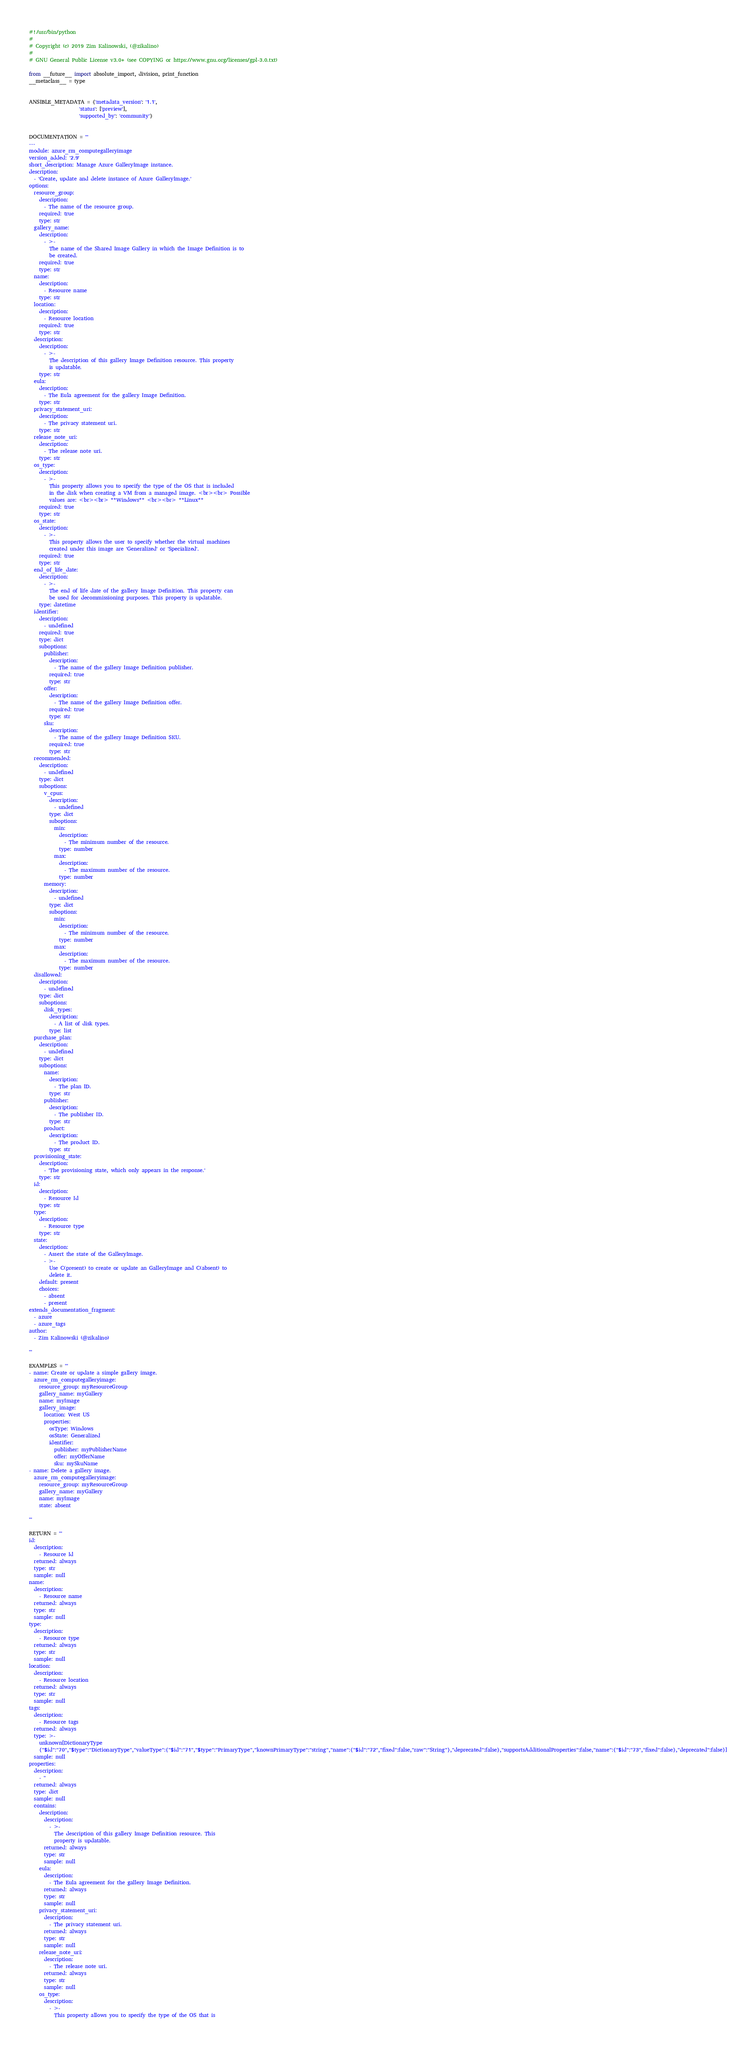Convert code to text. <code><loc_0><loc_0><loc_500><loc_500><_Python_>#!/usr/bin/python
#
# Copyright (c) 2019 Zim Kalinowski, (@zikalino)
#
# GNU General Public License v3.0+ (see COPYING or https://www.gnu.org/licenses/gpl-3.0.txt)

from __future__ import absolute_import, division, print_function
__metaclass__ = type


ANSIBLE_METADATA = {'metadata_version': '1.1',
                    'status': ['preview'],
                    'supported_by': 'community'}


DOCUMENTATION = '''
---
module: azure_rm_computegalleryimage
version_added: '2.9'
short_description: Manage Azure GalleryImage instance.
description:
  - 'Create, update and delete instance of Azure GalleryImage.'
options:
  resource_group:
    description:
      - The name of the resource group.
    required: true
    type: str
  gallery_name:
    description:
      - >-
        The name of the Shared Image Gallery in which the Image Definition is to
        be created.
    required: true
    type: str
  name:
    description:
      - Resource name
    type: str
  location:
    description:
      - Resource location
    required: true
    type: str
  description:
    description:
      - >-
        The description of this gallery Image Definition resource. This property
        is updatable.
    type: str
  eula:
    description:
      - The Eula agreement for the gallery Image Definition.
    type: str
  privacy_statement_uri:
    description:
      - The privacy statement uri.
    type: str
  release_note_uri:
    description:
      - The release note uri.
    type: str
  os_type:
    description:
      - >-
        This property allows you to specify the type of the OS that is included
        in the disk when creating a VM from a managed image. <br><br> Possible
        values are: <br><br> **Windows** <br><br> **Linux**
    required: true
    type: str
  os_state:
    description:
      - >-
        This property allows the user to specify whether the virtual machines
        created under this image are 'Generalized' or 'Specialized'.
    required: true
    type: str
  end_of_life_date:
    description:
      - >-
        The end of life date of the gallery Image Definition. This property can
        be used for decommissioning purposes. This property is updatable.
    type: datetime
  identifier:
    description:
      - undefined
    required: true
    type: dict
    suboptions:
      publisher:
        description:
          - The name of the gallery Image Definition publisher.
        required: true
        type: str
      offer:
        description:
          - The name of the gallery Image Definition offer.
        required: true
        type: str
      sku:
        description:
          - The name of the gallery Image Definition SKU.
        required: true
        type: str
  recommended:
    description:
      - undefined
    type: dict
    suboptions:
      v_cpus:
        description:
          - undefined
        type: dict
        suboptions:
          min:
            description:
              - The minimum number of the resource.
            type: number
          max:
            description:
              - The maximum number of the resource.
            type: number
      memory:
        description:
          - undefined
        type: dict
        suboptions:
          min:
            description:
              - The minimum number of the resource.
            type: number
          max:
            description:
              - The maximum number of the resource.
            type: number
  disallowed:
    description:
      - undefined
    type: dict
    suboptions:
      disk_types:
        description:
          - A list of disk types.
        type: list
  purchase_plan:
    description:
      - undefined
    type: dict
    suboptions:
      name:
        description:
          - The plan ID.
        type: str
      publisher:
        description:
          - The publisher ID.
        type: str
      product:
        description:
          - The product ID.
        type: str
  provisioning_state:
    description:
      - 'The provisioning state, which only appears in the response.'
    type: str
  id:
    description:
      - Resource Id
    type: str
  type:
    description:
      - Resource type
    type: str
  state:
    description:
      - Assert the state of the GalleryImage.
      - >-
        Use C(present) to create or update an GalleryImage and C(absent) to
        delete it.
    default: present
    choices:
      - absent
      - present
extends_documentation_fragment:
  - azure
  - azure_tags
author:
  - Zim Kalinowski (@zikalino)

'''

EXAMPLES = '''
- name: Create or update a simple gallery image.
  azure_rm_computegalleryimage:
    resource_group: myResourceGroup
    gallery_name: myGallery
    name: myImage
    gallery_image:
      location: West US
      properties:
        osType: Windows
        osState: Generalized
        identifier:
          publisher: myPublisherName
          offer: myOfferName
          sku: mySkuName
- name: Delete a gallery image.
  azure_rm_computegalleryimage:
    resource_group: myResourceGroup
    gallery_name: myGallery
    name: myImage
    state: absent

'''

RETURN = '''
id:
  description:
    - Resource Id
  returned: always
  type: str
  sample: null
name:
  description:
    - Resource name
  returned: always
  type: str
  sample: null
type:
  description:
    - Resource type
  returned: always
  type: str
  sample: null
location:
  description:
    - Resource location
  returned: always
  type: str
  sample: null
tags:
  description:
    - Resource tags
  returned: always
  type: >-
    unknown[DictionaryType
    {"$id":"70","$type":"DictionaryType","valueType":{"$id":"71","$type":"PrimaryType","knownPrimaryType":"string","name":{"$id":"72","fixed":false,"raw":"String"},"deprecated":false},"supportsAdditionalProperties":false,"name":{"$id":"73","fixed":false},"deprecated":false}]
  sample: null
properties:
  description:
    - ''
  returned: always
  type: dict
  sample: null
  contains:
    description:
      description:
        - >-
          The description of this gallery Image Definition resource. This
          property is updatable.
      returned: always
      type: str
      sample: null
    eula:
      description:
        - The Eula agreement for the gallery Image Definition.
      returned: always
      type: str
      sample: null
    privacy_statement_uri:
      description:
        - The privacy statement uri.
      returned: always
      type: str
      sample: null
    release_note_uri:
      description:
        - The release note uri.
      returned: always
      type: str
      sample: null
    os_type:
      description:
        - >-
          This property allows you to specify the type of the OS that is</code> 